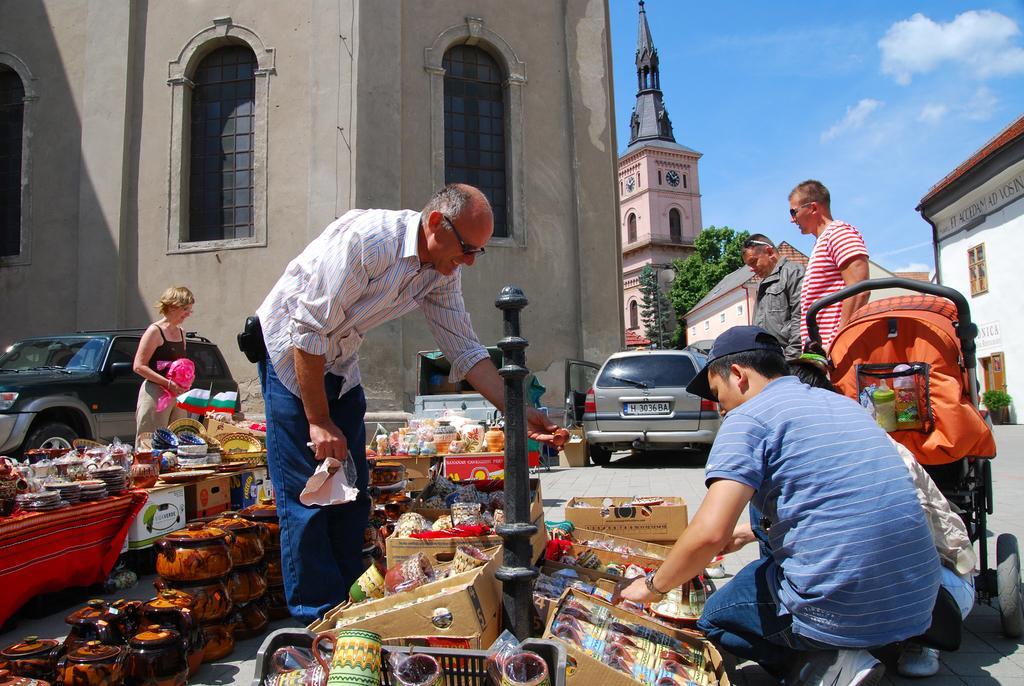Could you give a brief overview of what you see in this image? In the image we can see there are people standing and some of them are sitting, they are wearing clothes and some of them are wearing goggles and a cap. Here we can see post, boxes, cups and many other things. We can even see there are vehicles on the road. There are even buildings and these are the windows of the building. Here we can see clock, trees, plant, baby cart and a cloudy sky.  